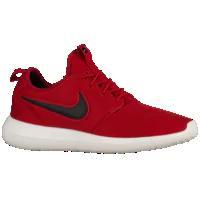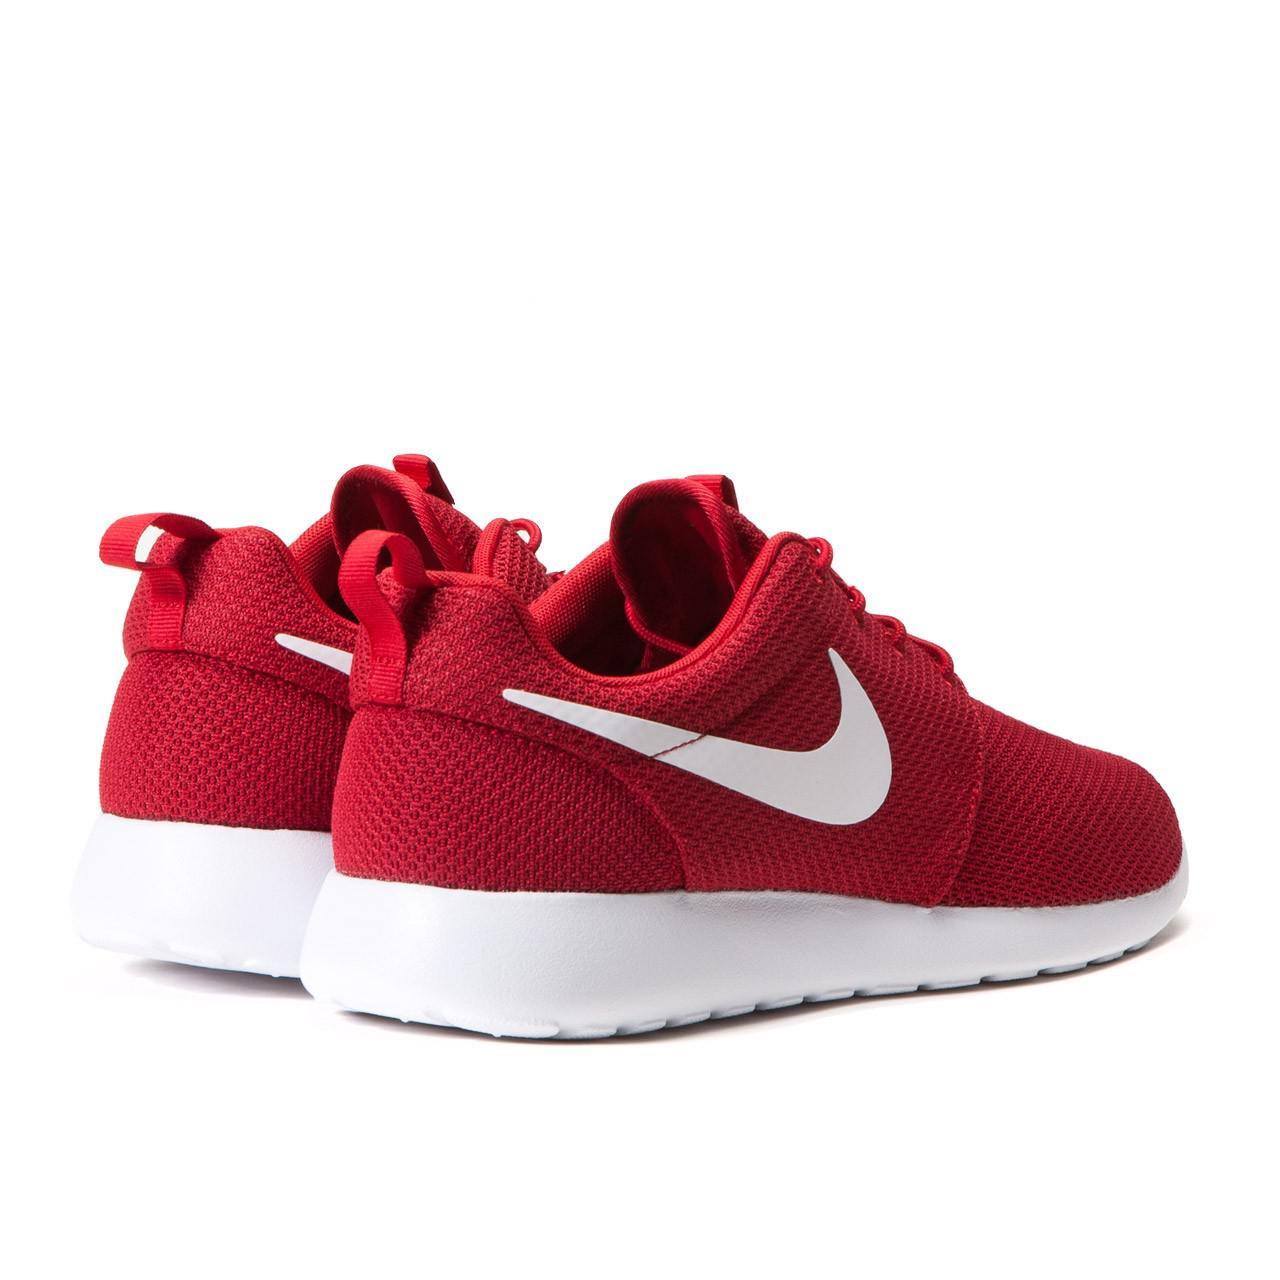The first image is the image on the left, the second image is the image on the right. Evaluate the accuracy of this statement regarding the images: "One image shows a pair of sneakers, with one shoe posed with the sole facing the camera and the other shoe pointed rightward, and the other image shows a single sneaker turned leftward.". Is it true? Answer yes or no. No. The first image is the image on the left, the second image is the image on the right. For the images shown, is this caption "The right image contains no more than one shoe." true? Answer yes or no. No. 